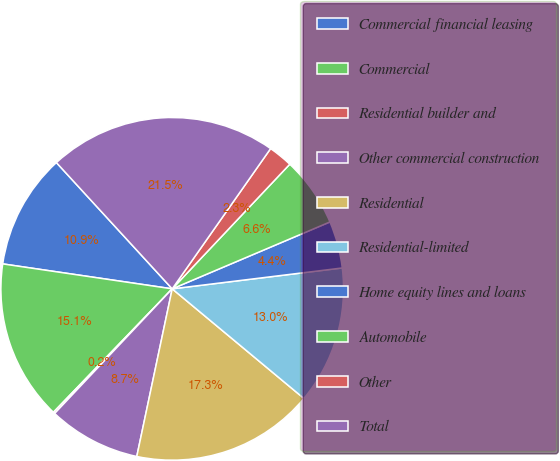Convert chart. <chart><loc_0><loc_0><loc_500><loc_500><pie_chart><fcel>Commercial financial leasing<fcel>Commercial<fcel>Residential builder and<fcel>Other commercial construction<fcel>Residential<fcel>Residential-limited<fcel>Home equity lines and loans<fcel>Automobile<fcel>Other<fcel>Total<nl><fcel>10.86%<fcel>15.13%<fcel>0.16%<fcel>8.72%<fcel>17.27%<fcel>12.99%<fcel>4.44%<fcel>6.58%<fcel>2.3%<fcel>21.55%<nl></chart> 